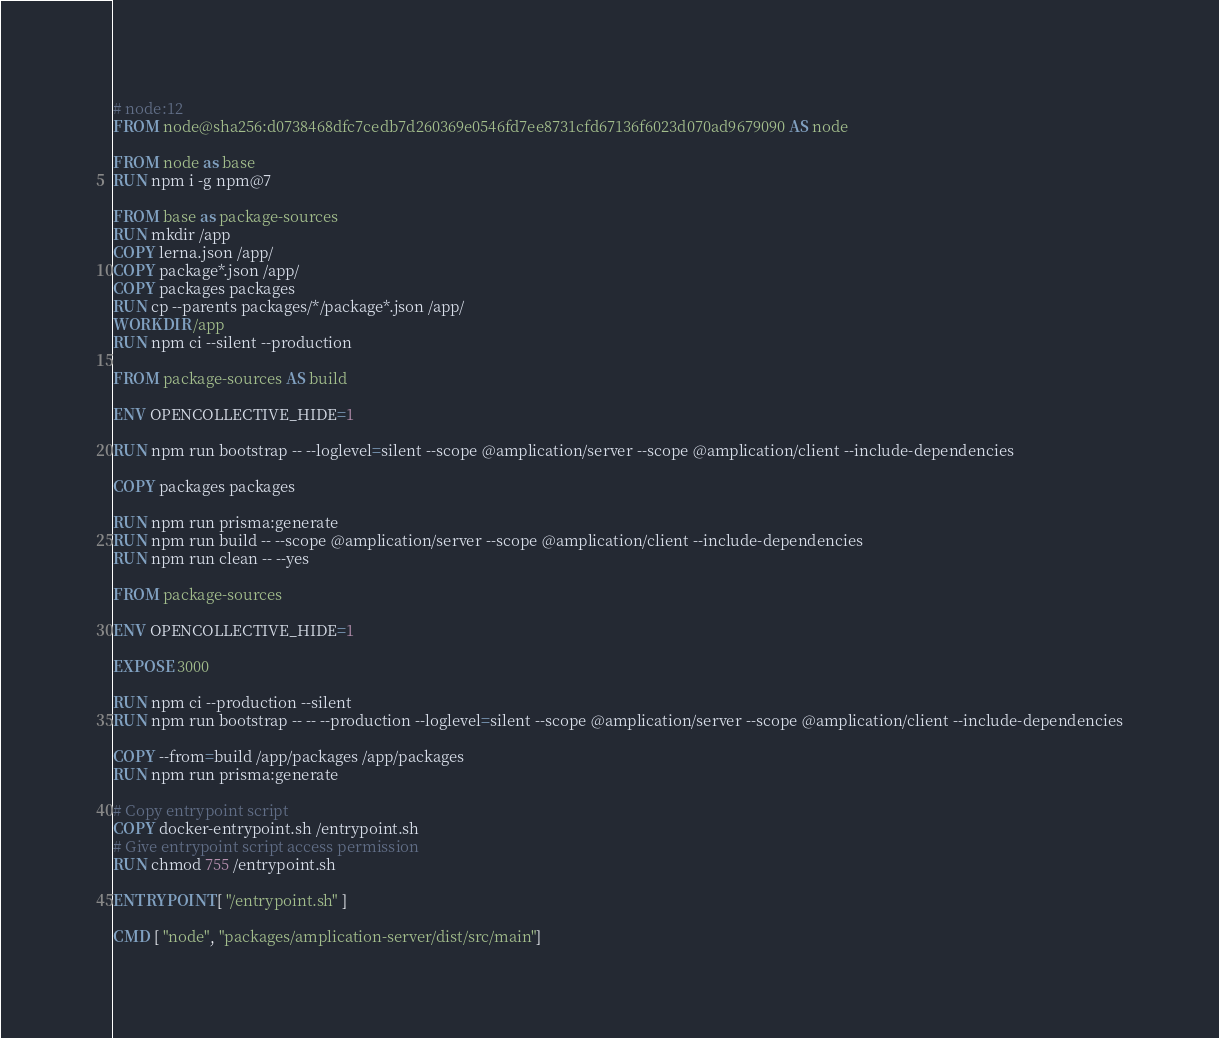<code> <loc_0><loc_0><loc_500><loc_500><_Dockerfile_># node:12
FROM node@sha256:d0738468dfc7cedb7d260369e0546fd7ee8731cfd67136f6023d070ad9679090 AS node

FROM node as base
RUN npm i -g npm@7

FROM base as package-sources
RUN mkdir /app
COPY lerna.json /app/
COPY package*.json /app/
COPY packages packages
RUN cp --parents packages/*/package*.json /app/
WORKDIR /app
RUN npm ci --silent --production

FROM package-sources AS build

ENV OPENCOLLECTIVE_HIDE=1

RUN npm run bootstrap -- --loglevel=silent --scope @amplication/server --scope @amplication/client --include-dependencies

COPY packages packages

RUN npm run prisma:generate
RUN npm run build -- --scope @amplication/server --scope @amplication/client --include-dependencies
RUN npm run clean -- --yes

FROM package-sources

ENV OPENCOLLECTIVE_HIDE=1

EXPOSE 3000

RUN npm ci --production --silent
RUN npm run bootstrap -- -- --production --loglevel=silent --scope @amplication/server --scope @amplication/client --include-dependencies

COPY --from=build /app/packages /app/packages
RUN npm run prisma:generate

# Copy entrypoint script
COPY docker-entrypoint.sh /entrypoint.sh
# Give entrypoint script access permission
RUN chmod 755 /entrypoint.sh

ENTRYPOINT [ "/entrypoint.sh" ]

CMD [ "node", "packages/amplication-server/dist/src/main"]</code> 